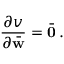Convert formula to latex. <formula><loc_0><loc_0><loc_500><loc_500>\frac { \partial v } { \partial \bar { w } } = \bar { 0 } \, .</formula> 